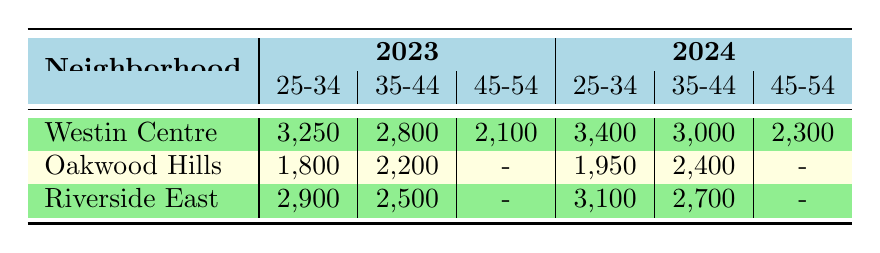What is the population of the 25-34 age group in Westin Centre for 2023? The value for the 25-34 age group in Westin Centre for 2023 is listed directly in the table. It is found in the cell under the "2023" column and "25-34" row for Westin Centre.
Answer: 3,250 How many people in the 35-44 age group lived in Oakwood Hills in 2024? The population for the 35-44 age group in Oakwood Hills for 2024 is located in the table under the "2024" column and "35-44" row for Oakwood Hills. This value is indicated without need for calculation.
Answer: 2,400 Is the population of the 45-54 age group in Riverside East data available for 2023? The table shows no entry for the 45-54 age group in Riverside East for 2023. It is represented with a dash (-), indicating data is missing for that year and age group.
Answer: No Which neighborhood had the highest population in the 25-34 age group in 2024? In the 25-34 age group column for 2024, Westin Centre has a population of 3,400, Riverside East has 3,100, and Oakwood Hills has 1,950. Comparing these values shows that Westin Centre has the highest population in this age group for that year.
Answer: Westin Centre What is the total population of the 35-44 age group in Westin Centre for both years? To find the total population in the 35-44 age group for Westin Centre across both years, add the populations from 2023 (2,800) and 2024 (3,000). This totals 2,800 + 3,000 = 5,800.
Answer: 5,800 Is the population of the 25-34 age group in Riverside East higher in 2024 than in 2023? The population in Riverside East for the 25-34 age group in 2023 is 2,900 and in 2024 it is 3,100. Since 3,100 is greater than 2,900, it indicates an increase in population for this age group.
Answer: Yes What is the average population of the 45-54 age group across all neighborhoods for 2024? The values for the 45-54 age group in 2024 are: Westin Centre has 2,300, Oakwood Hills has no data (-), and Riverside East has no data (-). Since we can only include the data point from Westin Centre, the average is calculated simply as the total (2,300) divided by the count of valid entries (1), giving an average of 2,300.
Answer: 2,300 Which neighborhood in 2023 had a population of 2,100 in the 45-54 age group? According to the table, only Westin Centre has an entry for the 45-54 age group for 2023, and the population is listed as 2,100. Therefore, Westin Centre is the answer to this question.
Answer: Westin Centre What was the overall change in population for the 25-34 age group in Westin Centre from 2023 to 2024? The population for the 25-34 age group in Westin Centre is 3,250 for 2023 and increases to 3,400 in 2024. The overall change is calculated as 3,400 - 3,250, which equals 150.
Answer: 150 